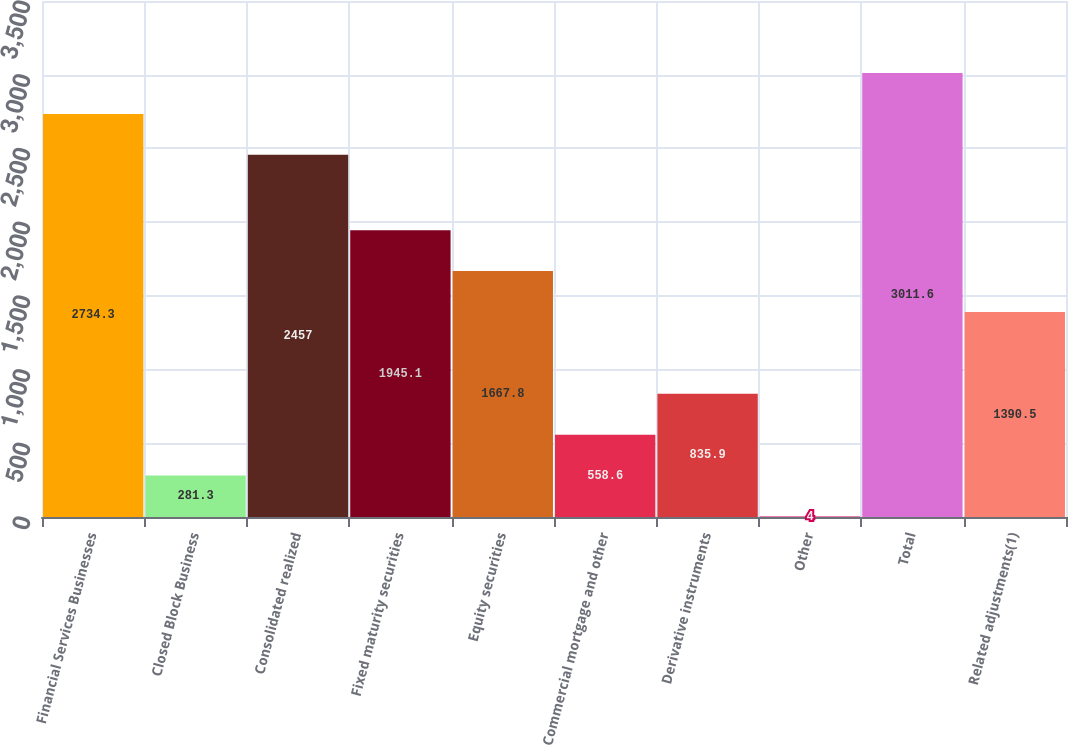Convert chart. <chart><loc_0><loc_0><loc_500><loc_500><bar_chart><fcel>Financial Services Businesses<fcel>Closed Block Business<fcel>Consolidated realized<fcel>Fixed maturity securities<fcel>Equity securities<fcel>Commercial mortgage and other<fcel>Derivative instruments<fcel>Other<fcel>Total<fcel>Related adjustments(1)<nl><fcel>2734.3<fcel>281.3<fcel>2457<fcel>1945.1<fcel>1667.8<fcel>558.6<fcel>835.9<fcel>4<fcel>3011.6<fcel>1390.5<nl></chart> 